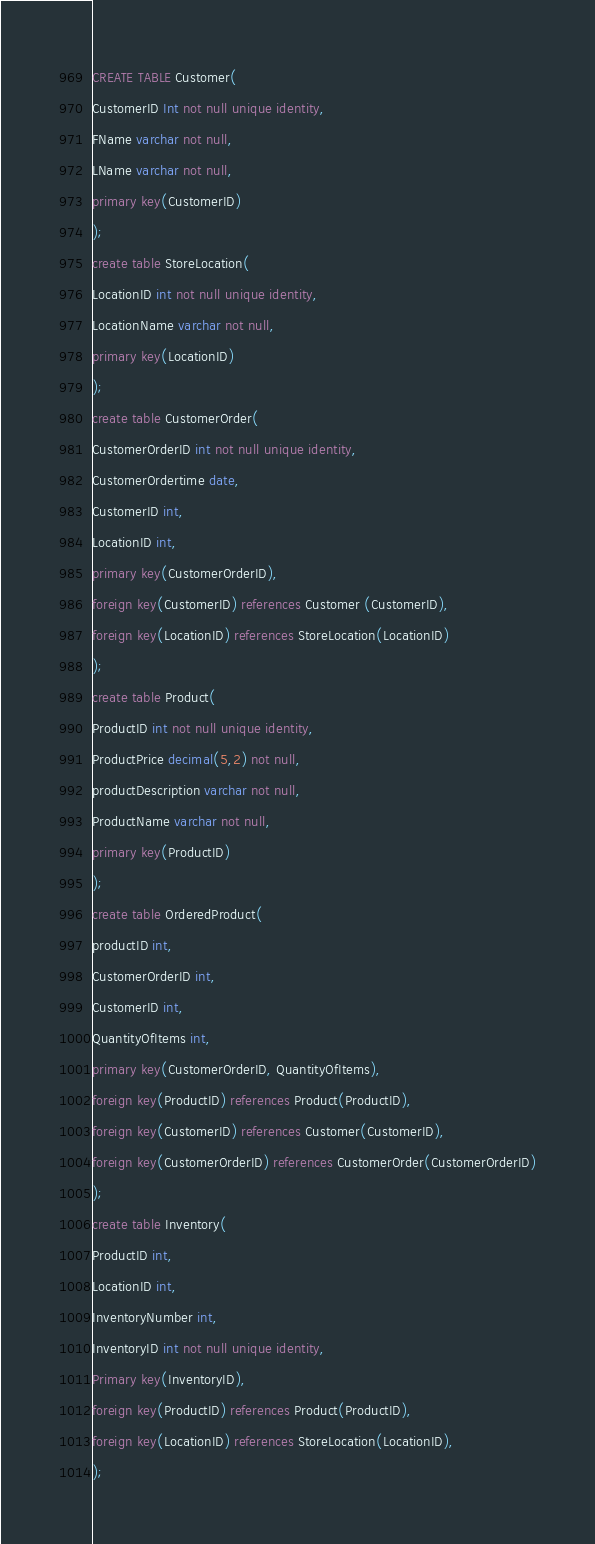<code> <loc_0><loc_0><loc_500><loc_500><_SQL_>CREATE TABLE Customer(
CustomerID Int not null unique identity,
FName varchar not null,
LName varchar not null,
primary key(CustomerID)
);
create table StoreLocation(
LocationID int not null unique identity,
LocationName varchar not null,
primary key(LocationID)
);
create table CustomerOrder(
CustomerOrderID int not null unique identity,
CustomerOrdertime date,
CustomerID int,
LocationID int,
primary key(CustomerOrderID),
foreign key(CustomerID) references Customer (CustomerID),
foreign key(LocationID) references StoreLocation(LocationID)
);
create table Product(
ProductID int not null unique identity,
ProductPrice decimal(5,2) not null,
productDescription varchar not null,
ProductName varchar not null,
primary key(ProductID) 
);
create table OrderedProduct(
productID int,
CustomerOrderID int,
CustomerID int,
QuantityOfItems int,
primary key(CustomerOrderID, QuantityOfItems),
foreign key(ProductID) references Product(ProductID),
foreign key(CustomerID) references Customer(CustomerID),
foreign key(CustomerOrderID) references CustomerOrder(CustomerOrderID)
);
create table Inventory(
ProductID int,
LocationID int,
InventoryNumber int,
InventoryID int not null unique identity,
Primary key(InventoryID),
foreign key(ProductID) references Product(ProductID),
foreign key(LocationID) references StoreLocation(LocationID),
);

</code> 